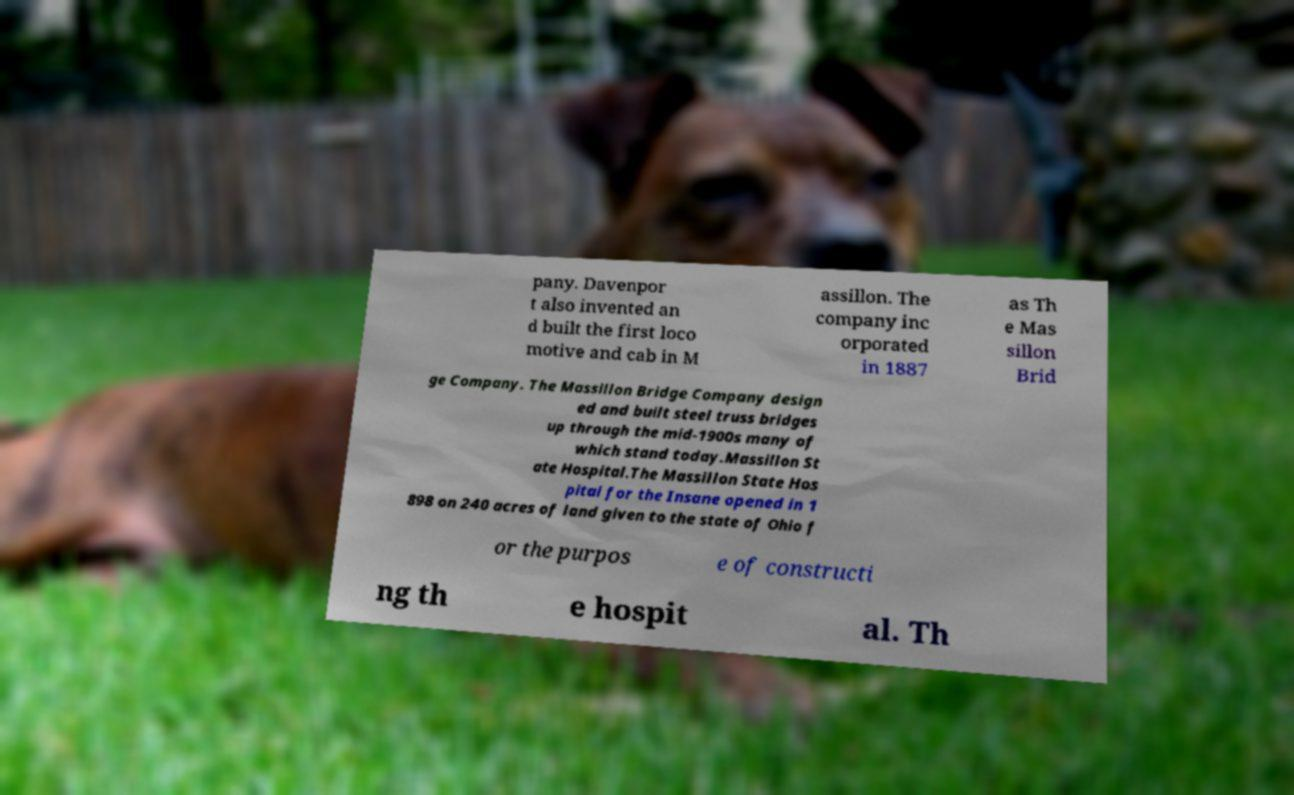I need the written content from this picture converted into text. Can you do that? pany. Davenpor t also invented an d built the first loco motive and cab in M assillon. The company inc orporated in 1887 as Th e Mas sillon Brid ge Company. The Massillon Bridge Company design ed and built steel truss bridges up through the mid-1900s many of which stand today.Massillon St ate Hospital.The Massillon State Hos pital for the Insane opened in 1 898 on 240 acres of land given to the state of Ohio f or the purpos e of constructi ng th e hospit al. Th 